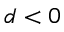Convert formula to latex. <formula><loc_0><loc_0><loc_500><loc_500>d < 0</formula> 